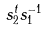Convert formula to latex. <formula><loc_0><loc_0><loc_500><loc_500>s _ { 2 } ^ { t } s _ { 1 } ^ { - 1 }</formula> 